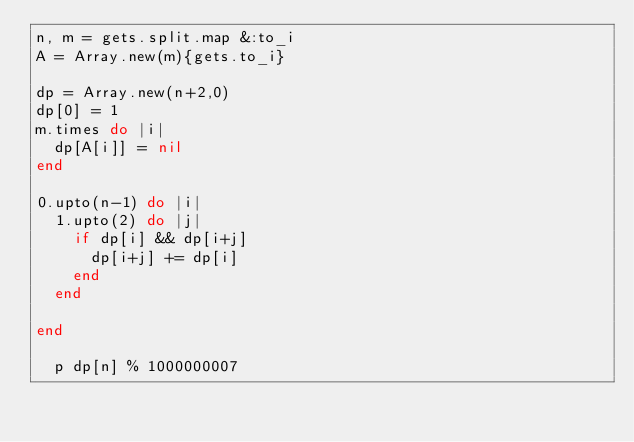<code> <loc_0><loc_0><loc_500><loc_500><_Ruby_>n, m = gets.split.map &:to_i
A = Array.new(m){gets.to_i}

dp = Array.new(n+2,0)
dp[0] = 1
m.times do |i|
  dp[A[i]] = nil
end

0.upto(n-1) do |i|
  1.upto(2) do |j|
    if dp[i] && dp[i+j]
      dp[i+j] += dp[i]
    end
  end
  
end

  p dp[n] % 1000000007
</code> 